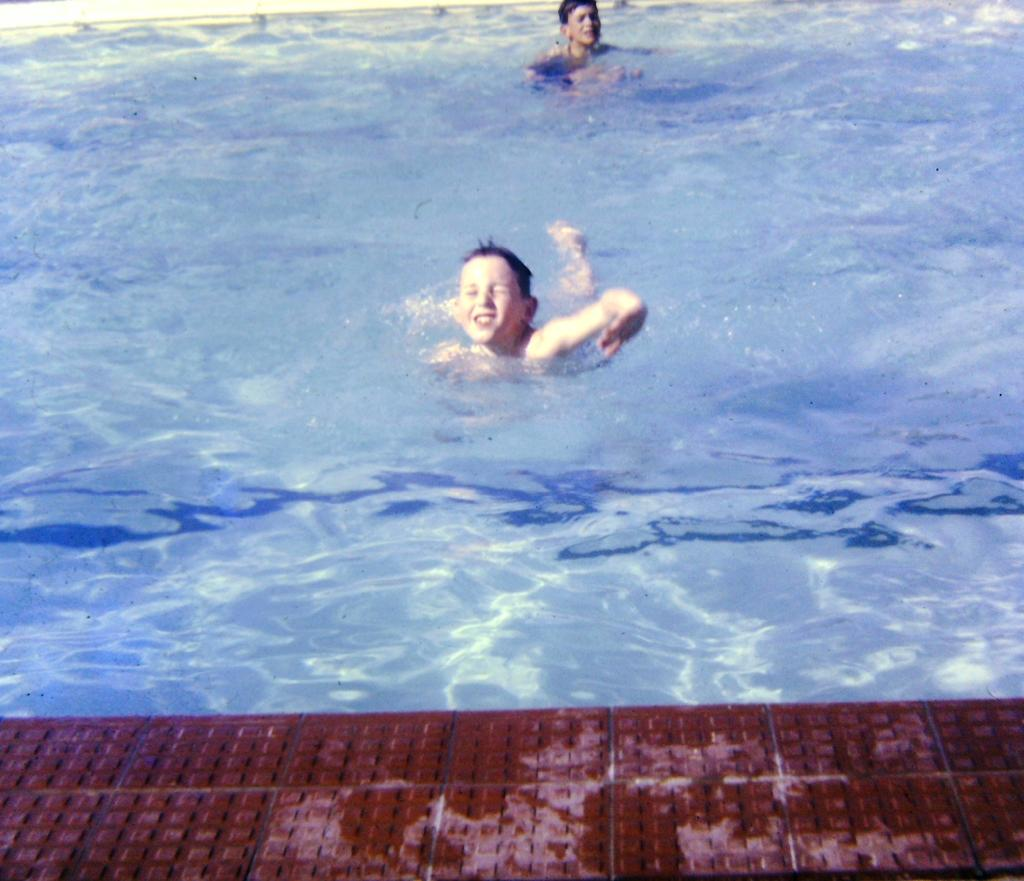Who is present in the image? There are children in the image. What are the children doing in the image? The children are swimming in a pool. What is the pool filled with? The pool is full of water. What type of head can be seen on the chicken in the image? There is no chicken present in the image; it features children swimming in a pool. What kind of stamp is visible on the children's hands in the image? There is no stamp visible on the children's hands in the image. 